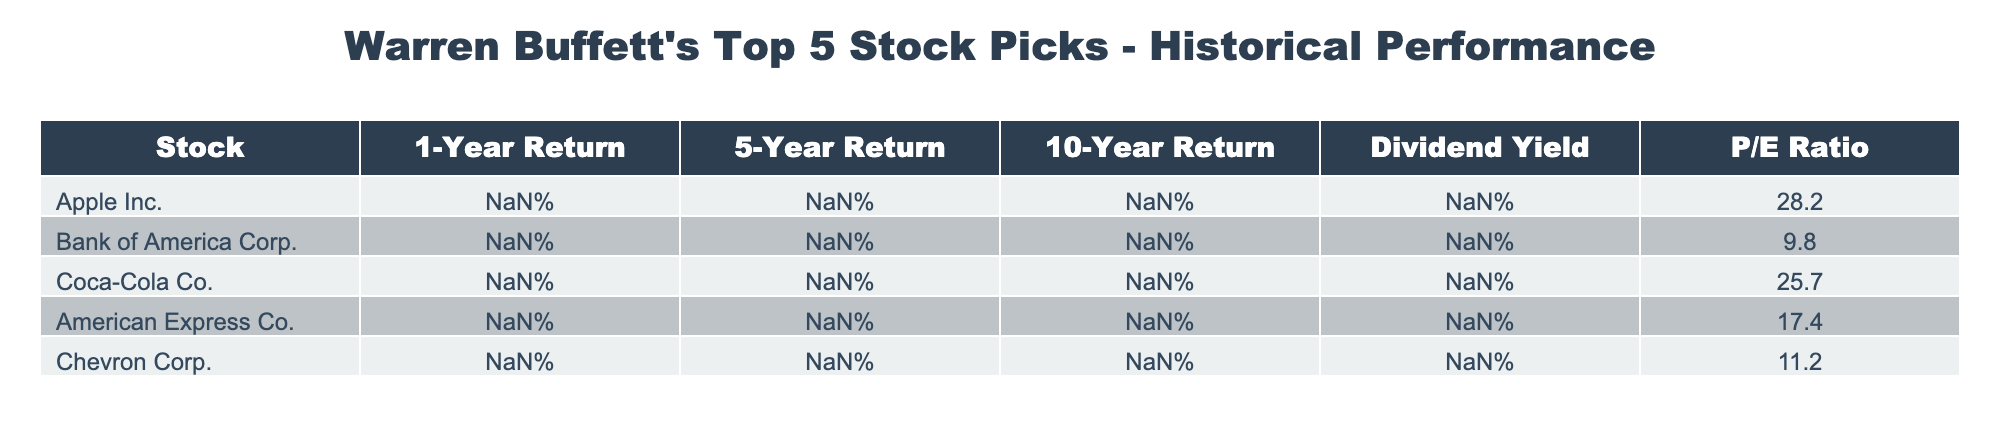What is the 1-Year Return for Apple Inc.? The 1-Year Return for Apple Inc. is listed in the table under the "1-Year Return" column. It shows a value of 32.8%.
Answer: 32.8% Which stock has the highest 10-Year Return? To find the stock with the highest 10-Year Return, we compare the values in the "10-Year Return" column. Apple Inc. has the highest value at 834.2%.
Answer: Apple Inc What is the average P/E Ratio of Warren Buffett's top 5 stock picks? First, we sum the P/E Ratios: (28.2 + 9.8 + 25.7 + 17.4 + 11.2) = 92.3. Then, we divide by the number of stocks, which is 5: 92.3 / 5 = 18.46.
Answer: 18.46 Is the Dividend Yield for Coca-Cola Co. greater than 2%? The Dividend Yield for Coca-Cola Co. is stated in the table as 3.1%. Since this value is greater than 2%, the answer is yes.
Answer: Yes Which stock has the lowest 5-Year Return, and what is that return? We examine the "5-Year Return" column and find that Bank of America Corp. has the lowest 5-Year Return at 68.4%.
Answer: Bank of America Corp. with 68.4% What is the difference in 10-Year Returns between American Express Co. and Chevron Corp.? The 10-Year Return for American Express Co. is 213.6%, and for Chevron Corp., it is 78.5%. The difference is calculated by subtracting Chevron's return from American Express's return: 213.6% - 78.5% = 135.1%.
Answer: 135.1% Is the Dividend Yield for Apple Inc. less than 1%? According to the table, Apple Inc. has a Dividend Yield of 0.5%, which is indeed less than 1%. Therefore, the answer is yes.
Answer: Yes What is the 5-Year Return of Chevron Corp.? The 5-Year Return for Chevron Corp. can be found under the corresponding column in the table, which shows a value of 52.8%.
Answer: 52.8% What percentage of the stocks have a Dividend Yield of 3% or higher? Out of the 5 stocks, Coca-Cola Co. and Chevron Corp. have a Dividend Yield of 3% or higher (3.1% and 3.5%, respectively). This is 2 out of 5 stocks, so the percentage is (2/5) * 100 = 40%.
Answer: 40% 